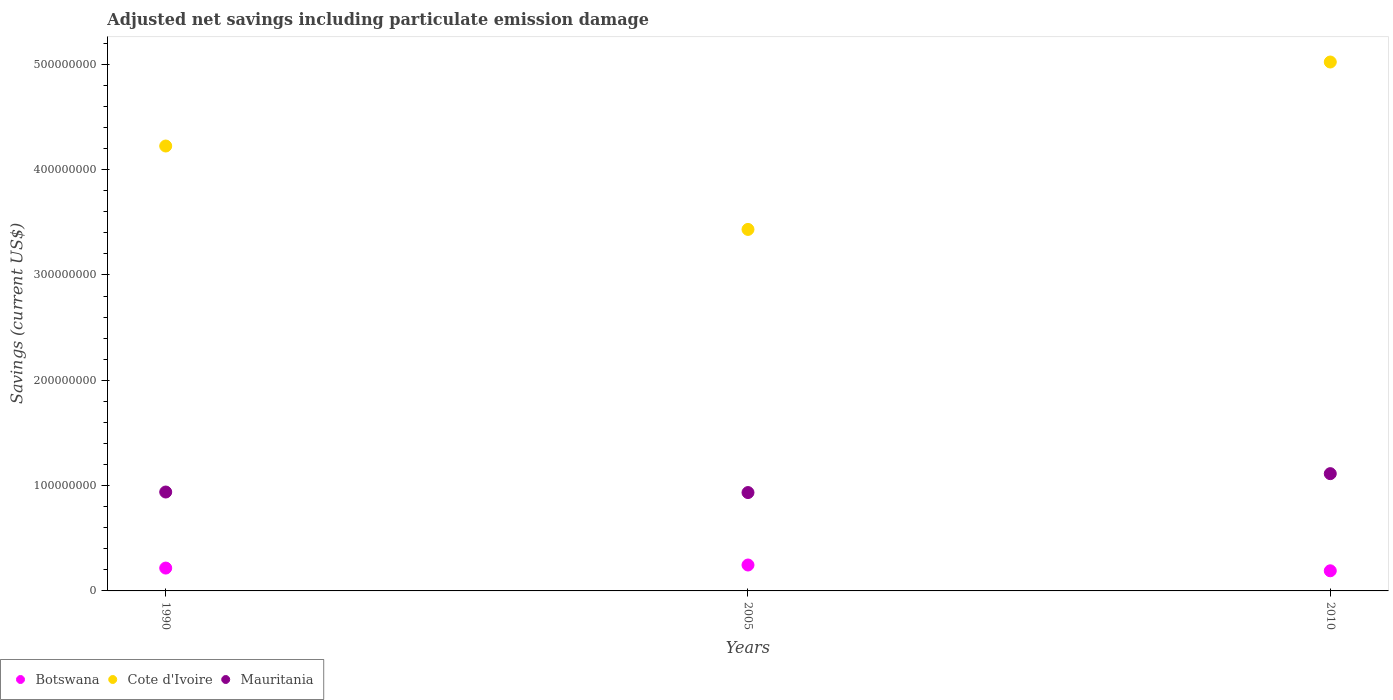What is the net savings in Mauritania in 2005?
Your answer should be very brief. 9.34e+07. Across all years, what is the maximum net savings in Cote d'Ivoire?
Keep it short and to the point. 5.02e+08. Across all years, what is the minimum net savings in Cote d'Ivoire?
Make the answer very short. 3.43e+08. In which year was the net savings in Botswana maximum?
Your answer should be very brief. 2005. In which year was the net savings in Botswana minimum?
Offer a very short reply. 2010. What is the total net savings in Botswana in the graph?
Give a very brief answer. 6.54e+07. What is the difference between the net savings in Botswana in 1990 and that in 2010?
Provide a succinct answer. 2.59e+06. What is the difference between the net savings in Cote d'Ivoire in 1990 and the net savings in Mauritania in 2010?
Offer a very short reply. 3.11e+08. What is the average net savings in Botswana per year?
Keep it short and to the point. 2.18e+07. In the year 2005, what is the difference between the net savings in Cote d'Ivoire and net savings in Botswana?
Ensure brevity in your answer.  3.19e+08. In how many years, is the net savings in Cote d'Ivoire greater than 500000000 US$?
Your response must be concise. 1. What is the ratio of the net savings in Cote d'Ivoire in 1990 to that in 2010?
Provide a short and direct response. 0.84. Is the net savings in Cote d'Ivoire in 1990 less than that in 2005?
Give a very brief answer. No. Is the difference between the net savings in Cote d'Ivoire in 2005 and 2010 greater than the difference between the net savings in Botswana in 2005 and 2010?
Your response must be concise. No. What is the difference between the highest and the second highest net savings in Cote d'Ivoire?
Offer a terse response. 7.98e+07. What is the difference between the highest and the lowest net savings in Cote d'Ivoire?
Make the answer very short. 1.59e+08. Does the net savings in Cote d'Ivoire monotonically increase over the years?
Provide a succinct answer. No. Is the net savings in Cote d'Ivoire strictly greater than the net savings in Botswana over the years?
Provide a short and direct response. Yes. How many dotlines are there?
Provide a succinct answer. 3. What is the difference between two consecutive major ticks on the Y-axis?
Give a very brief answer. 1.00e+08. Are the values on the major ticks of Y-axis written in scientific E-notation?
Offer a terse response. No. How many legend labels are there?
Ensure brevity in your answer.  3. How are the legend labels stacked?
Your answer should be compact. Horizontal. What is the title of the graph?
Make the answer very short. Adjusted net savings including particulate emission damage. What is the label or title of the Y-axis?
Your answer should be compact. Savings (current US$). What is the Savings (current US$) in Botswana in 1990?
Ensure brevity in your answer.  2.17e+07. What is the Savings (current US$) in Cote d'Ivoire in 1990?
Give a very brief answer. 4.22e+08. What is the Savings (current US$) in Mauritania in 1990?
Your response must be concise. 9.39e+07. What is the Savings (current US$) of Botswana in 2005?
Make the answer very short. 2.46e+07. What is the Savings (current US$) in Cote d'Ivoire in 2005?
Give a very brief answer. 3.43e+08. What is the Savings (current US$) in Mauritania in 2005?
Provide a succinct answer. 9.34e+07. What is the Savings (current US$) of Botswana in 2010?
Make the answer very short. 1.91e+07. What is the Savings (current US$) of Cote d'Ivoire in 2010?
Keep it short and to the point. 5.02e+08. What is the Savings (current US$) of Mauritania in 2010?
Your answer should be very brief. 1.11e+08. Across all years, what is the maximum Savings (current US$) of Botswana?
Provide a succinct answer. 2.46e+07. Across all years, what is the maximum Savings (current US$) in Cote d'Ivoire?
Give a very brief answer. 5.02e+08. Across all years, what is the maximum Savings (current US$) of Mauritania?
Provide a succinct answer. 1.11e+08. Across all years, what is the minimum Savings (current US$) of Botswana?
Give a very brief answer. 1.91e+07. Across all years, what is the minimum Savings (current US$) in Cote d'Ivoire?
Ensure brevity in your answer.  3.43e+08. Across all years, what is the minimum Savings (current US$) in Mauritania?
Ensure brevity in your answer.  9.34e+07. What is the total Savings (current US$) of Botswana in the graph?
Provide a short and direct response. 6.54e+07. What is the total Savings (current US$) of Cote d'Ivoire in the graph?
Provide a short and direct response. 1.27e+09. What is the total Savings (current US$) in Mauritania in the graph?
Provide a succinct answer. 2.99e+08. What is the difference between the Savings (current US$) in Botswana in 1990 and that in 2005?
Ensure brevity in your answer.  -2.91e+06. What is the difference between the Savings (current US$) in Cote d'Ivoire in 1990 and that in 2005?
Keep it short and to the point. 7.92e+07. What is the difference between the Savings (current US$) in Mauritania in 1990 and that in 2005?
Your answer should be very brief. 5.18e+05. What is the difference between the Savings (current US$) in Botswana in 1990 and that in 2010?
Make the answer very short. 2.59e+06. What is the difference between the Savings (current US$) of Cote d'Ivoire in 1990 and that in 2010?
Ensure brevity in your answer.  -7.98e+07. What is the difference between the Savings (current US$) in Mauritania in 1990 and that in 2010?
Your response must be concise. -1.74e+07. What is the difference between the Savings (current US$) in Botswana in 2005 and that in 2010?
Provide a succinct answer. 5.50e+06. What is the difference between the Savings (current US$) of Cote d'Ivoire in 2005 and that in 2010?
Offer a terse response. -1.59e+08. What is the difference between the Savings (current US$) of Mauritania in 2005 and that in 2010?
Provide a short and direct response. -1.80e+07. What is the difference between the Savings (current US$) in Botswana in 1990 and the Savings (current US$) in Cote d'Ivoire in 2005?
Make the answer very short. -3.22e+08. What is the difference between the Savings (current US$) in Botswana in 1990 and the Savings (current US$) in Mauritania in 2005?
Ensure brevity in your answer.  -7.17e+07. What is the difference between the Savings (current US$) of Cote d'Ivoire in 1990 and the Savings (current US$) of Mauritania in 2005?
Offer a terse response. 3.29e+08. What is the difference between the Savings (current US$) of Botswana in 1990 and the Savings (current US$) of Cote d'Ivoire in 2010?
Offer a terse response. -4.81e+08. What is the difference between the Savings (current US$) in Botswana in 1990 and the Savings (current US$) in Mauritania in 2010?
Provide a succinct answer. -8.96e+07. What is the difference between the Savings (current US$) in Cote d'Ivoire in 1990 and the Savings (current US$) in Mauritania in 2010?
Make the answer very short. 3.11e+08. What is the difference between the Savings (current US$) in Botswana in 2005 and the Savings (current US$) in Cote d'Ivoire in 2010?
Offer a terse response. -4.78e+08. What is the difference between the Savings (current US$) in Botswana in 2005 and the Savings (current US$) in Mauritania in 2010?
Offer a very short reply. -8.67e+07. What is the difference between the Savings (current US$) of Cote d'Ivoire in 2005 and the Savings (current US$) of Mauritania in 2010?
Your answer should be very brief. 2.32e+08. What is the average Savings (current US$) in Botswana per year?
Offer a terse response. 2.18e+07. What is the average Savings (current US$) of Cote d'Ivoire per year?
Offer a very short reply. 4.23e+08. What is the average Savings (current US$) in Mauritania per year?
Ensure brevity in your answer.  9.96e+07. In the year 1990, what is the difference between the Savings (current US$) of Botswana and Savings (current US$) of Cote d'Ivoire?
Offer a very short reply. -4.01e+08. In the year 1990, what is the difference between the Savings (current US$) of Botswana and Savings (current US$) of Mauritania?
Keep it short and to the point. -7.22e+07. In the year 1990, what is the difference between the Savings (current US$) of Cote d'Ivoire and Savings (current US$) of Mauritania?
Make the answer very short. 3.29e+08. In the year 2005, what is the difference between the Savings (current US$) of Botswana and Savings (current US$) of Cote d'Ivoire?
Keep it short and to the point. -3.19e+08. In the year 2005, what is the difference between the Savings (current US$) in Botswana and Savings (current US$) in Mauritania?
Give a very brief answer. -6.88e+07. In the year 2005, what is the difference between the Savings (current US$) of Cote d'Ivoire and Savings (current US$) of Mauritania?
Provide a short and direct response. 2.50e+08. In the year 2010, what is the difference between the Savings (current US$) in Botswana and Savings (current US$) in Cote d'Ivoire?
Your response must be concise. -4.83e+08. In the year 2010, what is the difference between the Savings (current US$) in Botswana and Savings (current US$) in Mauritania?
Your answer should be compact. -9.22e+07. In the year 2010, what is the difference between the Savings (current US$) of Cote d'Ivoire and Savings (current US$) of Mauritania?
Provide a succinct answer. 3.91e+08. What is the ratio of the Savings (current US$) of Botswana in 1990 to that in 2005?
Give a very brief answer. 0.88. What is the ratio of the Savings (current US$) in Cote d'Ivoire in 1990 to that in 2005?
Provide a succinct answer. 1.23. What is the ratio of the Savings (current US$) in Botswana in 1990 to that in 2010?
Your answer should be compact. 1.14. What is the ratio of the Savings (current US$) in Cote d'Ivoire in 1990 to that in 2010?
Provide a succinct answer. 0.84. What is the ratio of the Savings (current US$) in Mauritania in 1990 to that in 2010?
Keep it short and to the point. 0.84. What is the ratio of the Savings (current US$) of Botswana in 2005 to that in 2010?
Give a very brief answer. 1.29. What is the ratio of the Savings (current US$) in Cote d'Ivoire in 2005 to that in 2010?
Provide a short and direct response. 0.68. What is the ratio of the Savings (current US$) in Mauritania in 2005 to that in 2010?
Your answer should be compact. 0.84. What is the difference between the highest and the second highest Savings (current US$) in Botswana?
Give a very brief answer. 2.91e+06. What is the difference between the highest and the second highest Savings (current US$) of Cote d'Ivoire?
Provide a succinct answer. 7.98e+07. What is the difference between the highest and the second highest Savings (current US$) in Mauritania?
Ensure brevity in your answer.  1.74e+07. What is the difference between the highest and the lowest Savings (current US$) of Botswana?
Ensure brevity in your answer.  5.50e+06. What is the difference between the highest and the lowest Savings (current US$) of Cote d'Ivoire?
Keep it short and to the point. 1.59e+08. What is the difference between the highest and the lowest Savings (current US$) of Mauritania?
Give a very brief answer. 1.80e+07. 